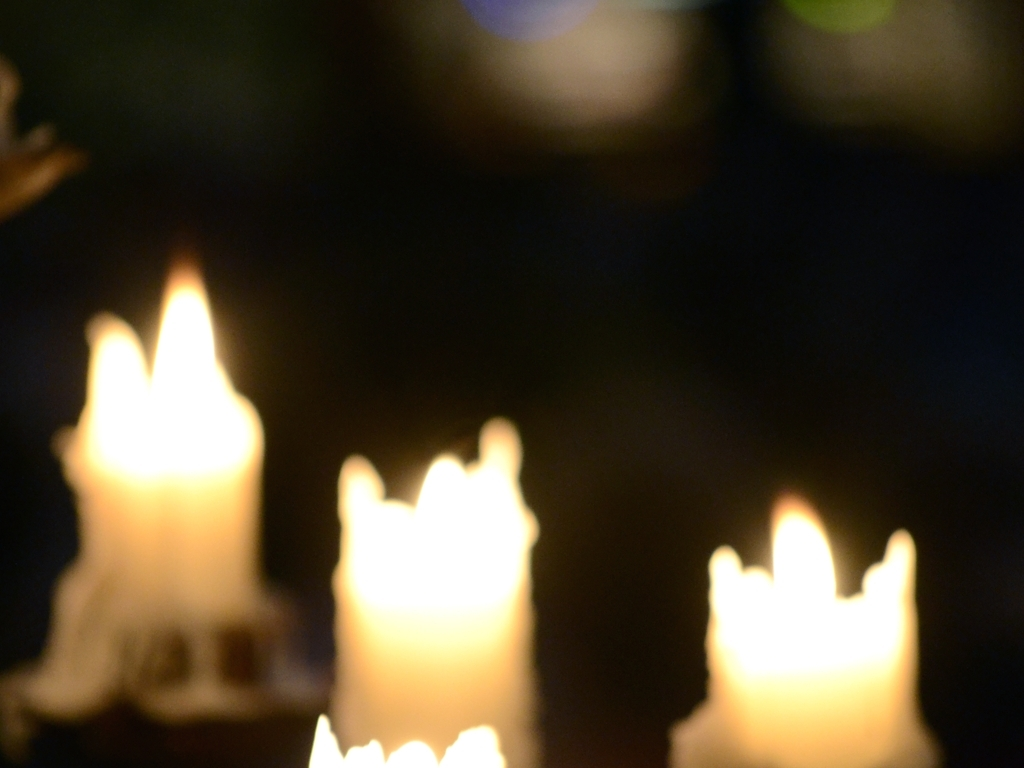Is the image sharp? No, the image is not sharp; it is blurry with an out of focus capture of what appears to be candles, creating a bokeh effect that might be intentional for aesthetic reasons. 